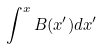Convert formula to latex. <formula><loc_0><loc_0><loc_500><loc_500>\int ^ { x } B ( x ^ { \prime } ) d x ^ { \prime }</formula> 